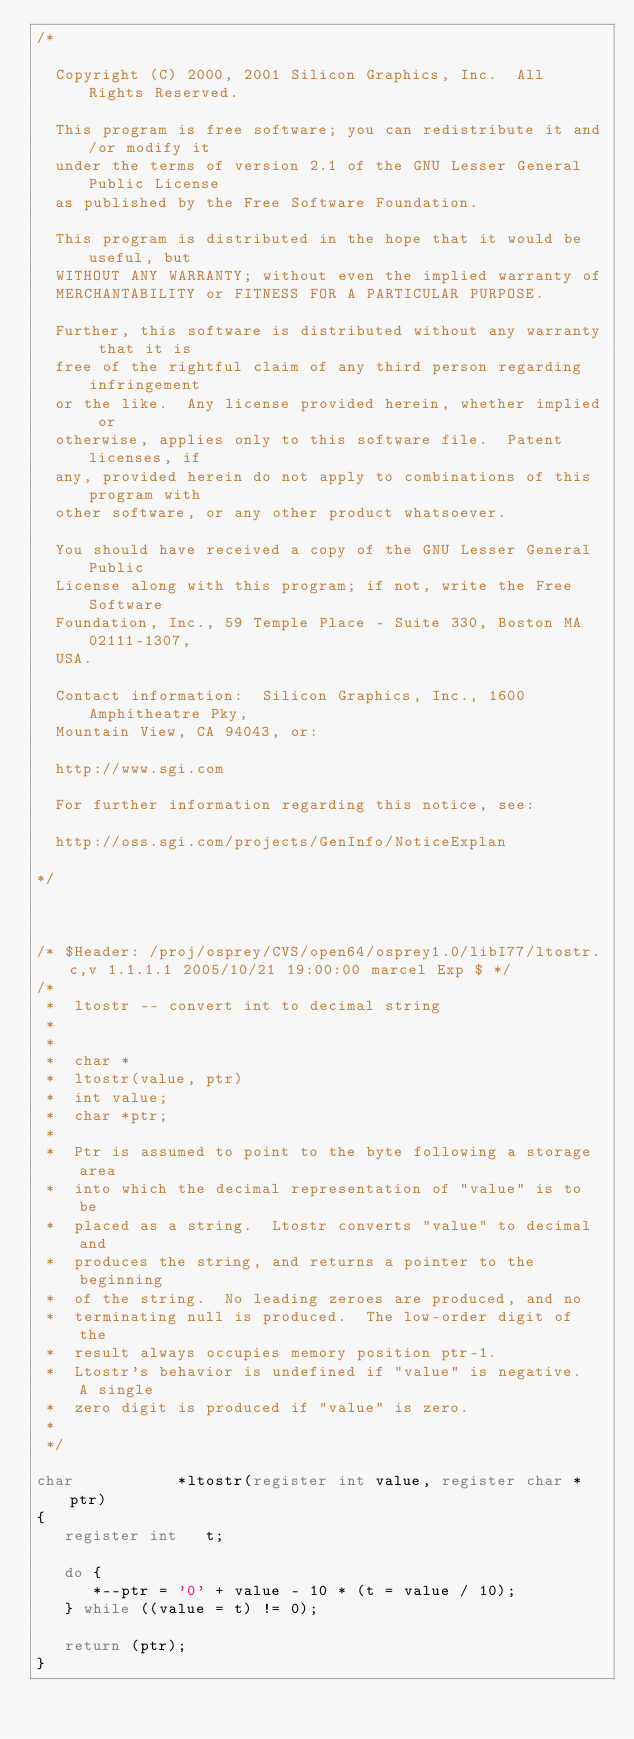Convert code to text. <code><loc_0><loc_0><loc_500><loc_500><_C_>/*

  Copyright (C) 2000, 2001 Silicon Graphics, Inc.  All Rights Reserved.

  This program is free software; you can redistribute it and/or modify it
  under the terms of version 2.1 of the GNU Lesser General Public License 
  as published by the Free Software Foundation.

  This program is distributed in the hope that it would be useful, but
  WITHOUT ANY WARRANTY; without even the implied warranty of
  MERCHANTABILITY or FITNESS FOR A PARTICULAR PURPOSE.  

  Further, this software is distributed without any warranty that it is
  free of the rightful claim of any third person regarding infringement 
  or the like.  Any license provided herein, whether implied or 
  otherwise, applies only to this software file.  Patent licenses, if
  any, provided herein do not apply to combinations of this program with 
  other software, or any other product whatsoever.  

  You should have received a copy of the GNU Lesser General Public 
  License along with this program; if not, write the Free Software 
  Foundation, Inc., 59 Temple Place - Suite 330, Boston MA 02111-1307, 
  USA.

  Contact information:  Silicon Graphics, Inc., 1600 Amphitheatre Pky,
  Mountain View, CA 94043, or:

  http://www.sgi.com

  For further information regarding this notice, see:

  http://oss.sgi.com/projects/GenInfo/NoticeExplan

*/



/* $Header: /proj/osprey/CVS/open64/osprey1.0/libI77/ltostr.c,v 1.1.1.1 2005/10/21 19:00:00 marcel Exp $ */
/*
 *	ltostr -- convert int to decimal string
 *
 *
 *	char *
 *	ltostr(value, ptr)
 *	int value;
 *	char *ptr;
 *
 *	Ptr is assumed to point to the byte following a storage area
 *	into which the decimal representation of "value" is to be
 *	placed as a string.  Ltostr converts "value" to decimal and
 *	produces the string, and returns a pointer to the beginning
 *	of the string.  No leading zeroes are produced, and no
 *	terminating null is produced.  The low-order digit of the
 *	result always occupies memory position ptr-1.
 *	Ltostr's behavior is undefined if "value" is negative.  A single
 *	zero digit is produced if "value" is zero.
 *
 */

char           *ltostr(register int value, register char *ptr)
{
   register int   t;

   do {
      *--ptr = '0' + value - 10 * (t = value / 10);
   } while ((value = t) != 0);

   return (ptr);
}
</code> 